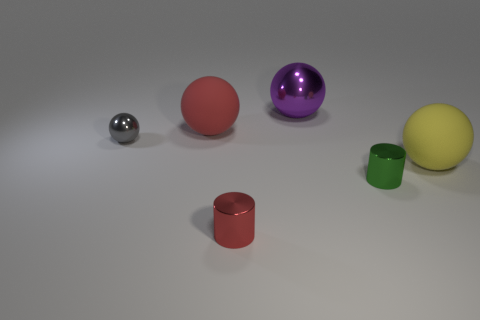What number of other objects are there of the same shape as the small gray object?
Keep it short and to the point. 3. How big is the rubber thing that is on the left side of the yellow rubber thing?
Your response must be concise. Large. There is a metal ball that is behind the tiny gray ball; how many small shiny cylinders are right of it?
Offer a very short reply. 1. Is the large metallic thing the same color as the tiny shiny ball?
Give a very brief answer. No. There is a large thing that is in front of the big red sphere; is it the same shape as the red rubber object?
Your answer should be very brief. Yes. How many balls are both in front of the big shiny ball and to the right of the gray thing?
Provide a succinct answer. 2. What material is the tiny ball?
Your answer should be compact. Metal. Is there any other thing of the same color as the tiny shiny ball?
Your answer should be very brief. No. Is the green object made of the same material as the yellow object?
Make the answer very short. No. What number of tiny metal cylinders are in front of the small cylinder to the right of the red object that is in front of the big yellow object?
Provide a short and direct response. 1. 